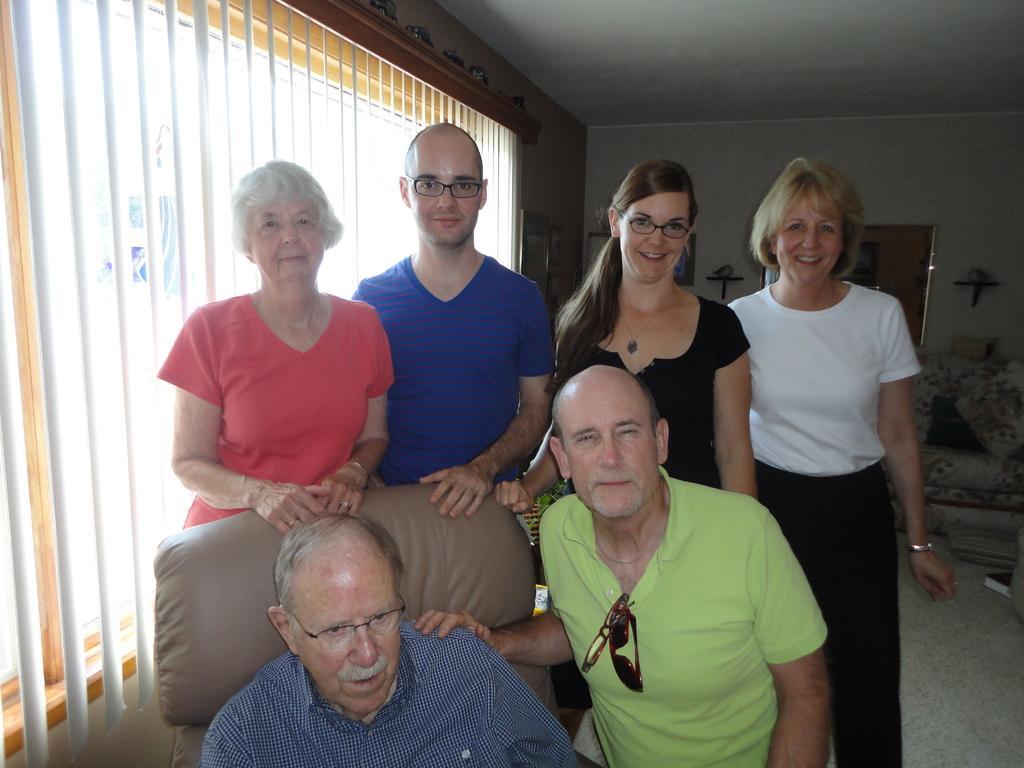Please provide a concise description of this image. In this image I see 3 men and 3 women in which this man is sitting on a chair and I see that these both women are smiling and in the background I see the floor and I see a couch over here and I see the wall and the ceiling. 